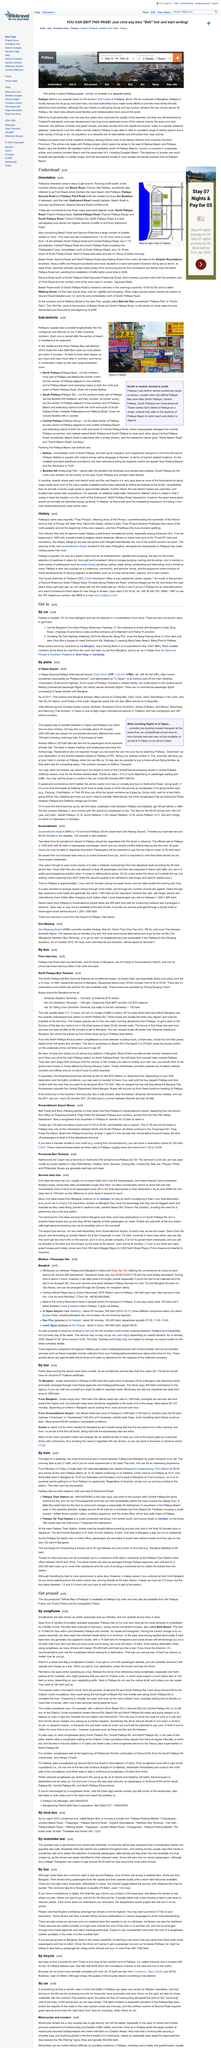Mention a couple of crucial points in this snapshot. It is a fact that third class trains do not have air-conditioning. It is advisable to negotiate taxi fares in advance from the Suvarnabhumi Airport in Suvarnabhumi to Pattaya, as such negotiation can result in a more favorable fare for the passenger. To rent a bicycle in the northern part of Pattaya, please contact 0808288239. The Official Map of Pattaya, which is produced by the City and is available at Pattaya City Hall, provides information on the city's various features and landmarks. The north-easterly wind at the beginning of the rainy season is named Phatthaya. 